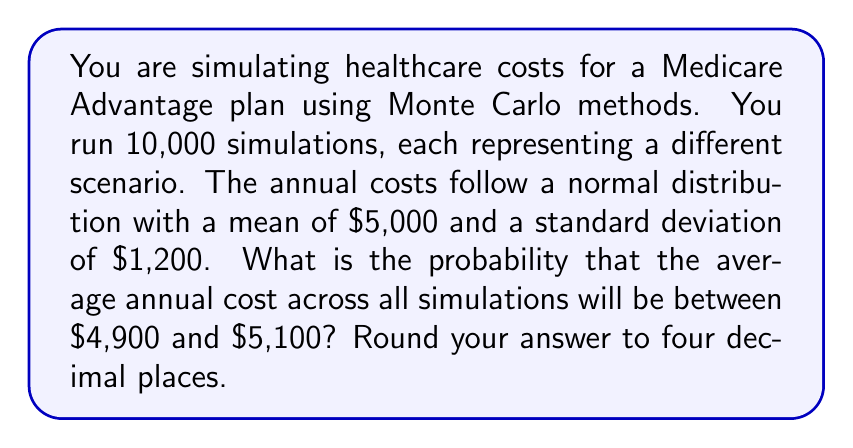What is the answer to this math problem? To solve this problem, we'll use the Central Limit Theorem and properties of normal distributions:

1) The Central Limit Theorem states that for a large number of independent random variables, their average follows a normal distribution.

2) Given:
   - Number of simulations: $n = 10,000$
   - Mean of individual costs: $\mu = \$5,000$
   - Standard deviation of individual costs: $\sigma = \$1,200$

3) The standard error of the mean (SEM) is:
   $$ SEM = \frac{\sigma}{\sqrt{n}} = \frac{1200}{\sqrt{10000}} = 12 $$

4) The distribution of the sample mean will be normal with:
   - Mean: $\mu = \$5,000$
   - Standard deviation: $SEM = \$12$

5) We want to find $P(4900 < X < 5100)$, where $X$ is the average cost.

6) Standardize the bounds:
   $$ z_{lower} = \frac{4900 - 5000}{12} = -8.33 $$
   $$ z_{upper} = \frac{5100 - 5000}{12} = 8.33 $$

7) Use the standard normal distribution to find the probability:
   $$ P(-8.33 < Z < 8.33) = \Phi(8.33) - \Phi(-8.33) $$
   where $\Phi$ is the cumulative distribution function of the standard normal distribution.

8) This probability is effectively 1, as it's extremely unlikely for the average to fall outside this range given the large number of simulations.

9) Rounding to four decimal places: 1.0000
Answer: 1.0000 